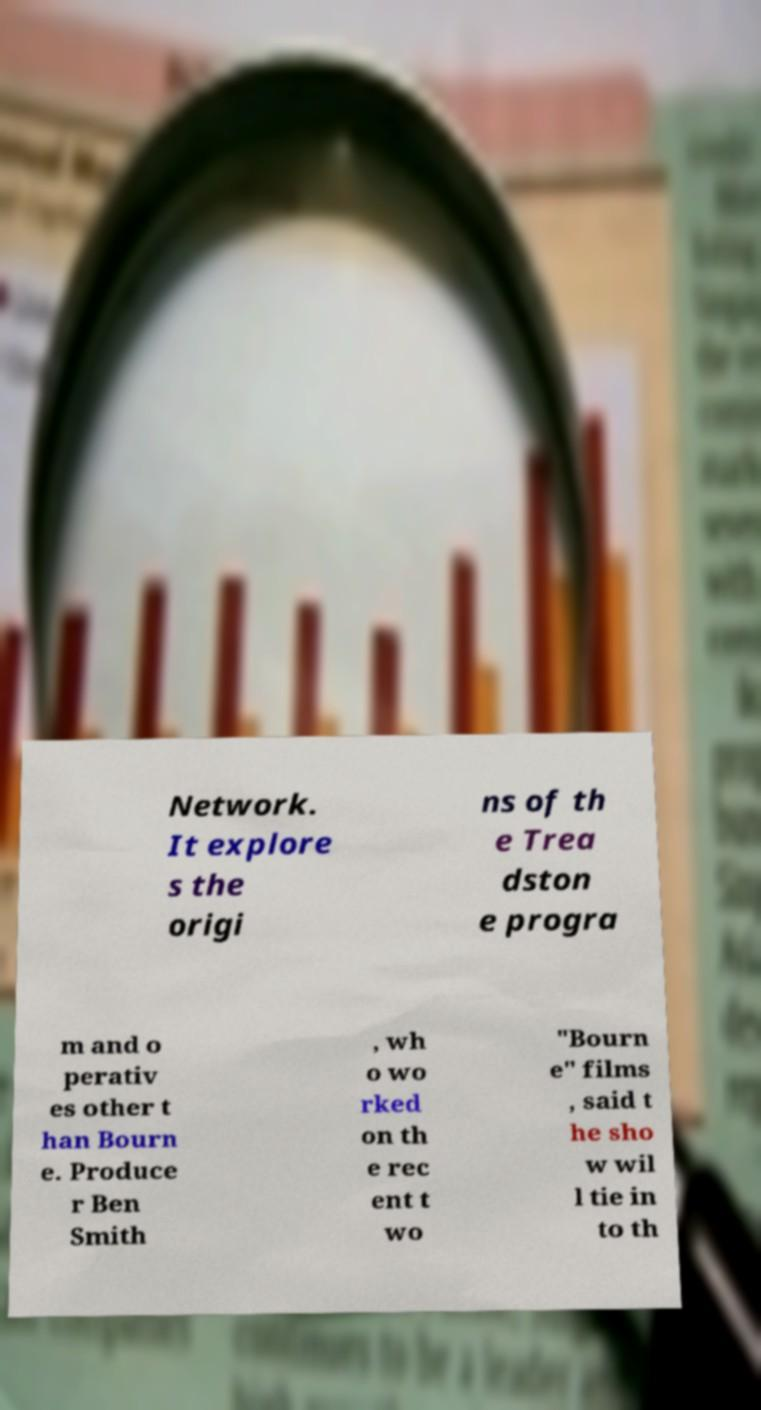Can you read and provide the text displayed in the image?This photo seems to have some interesting text. Can you extract and type it out for me? Network. It explore s the origi ns of th e Trea dston e progra m and o perativ es other t han Bourn e. Produce r Ben Smith , wh o wo rked on th e rec ent t wo "Bourn e" films , said t he sho w wil l tie in to th 